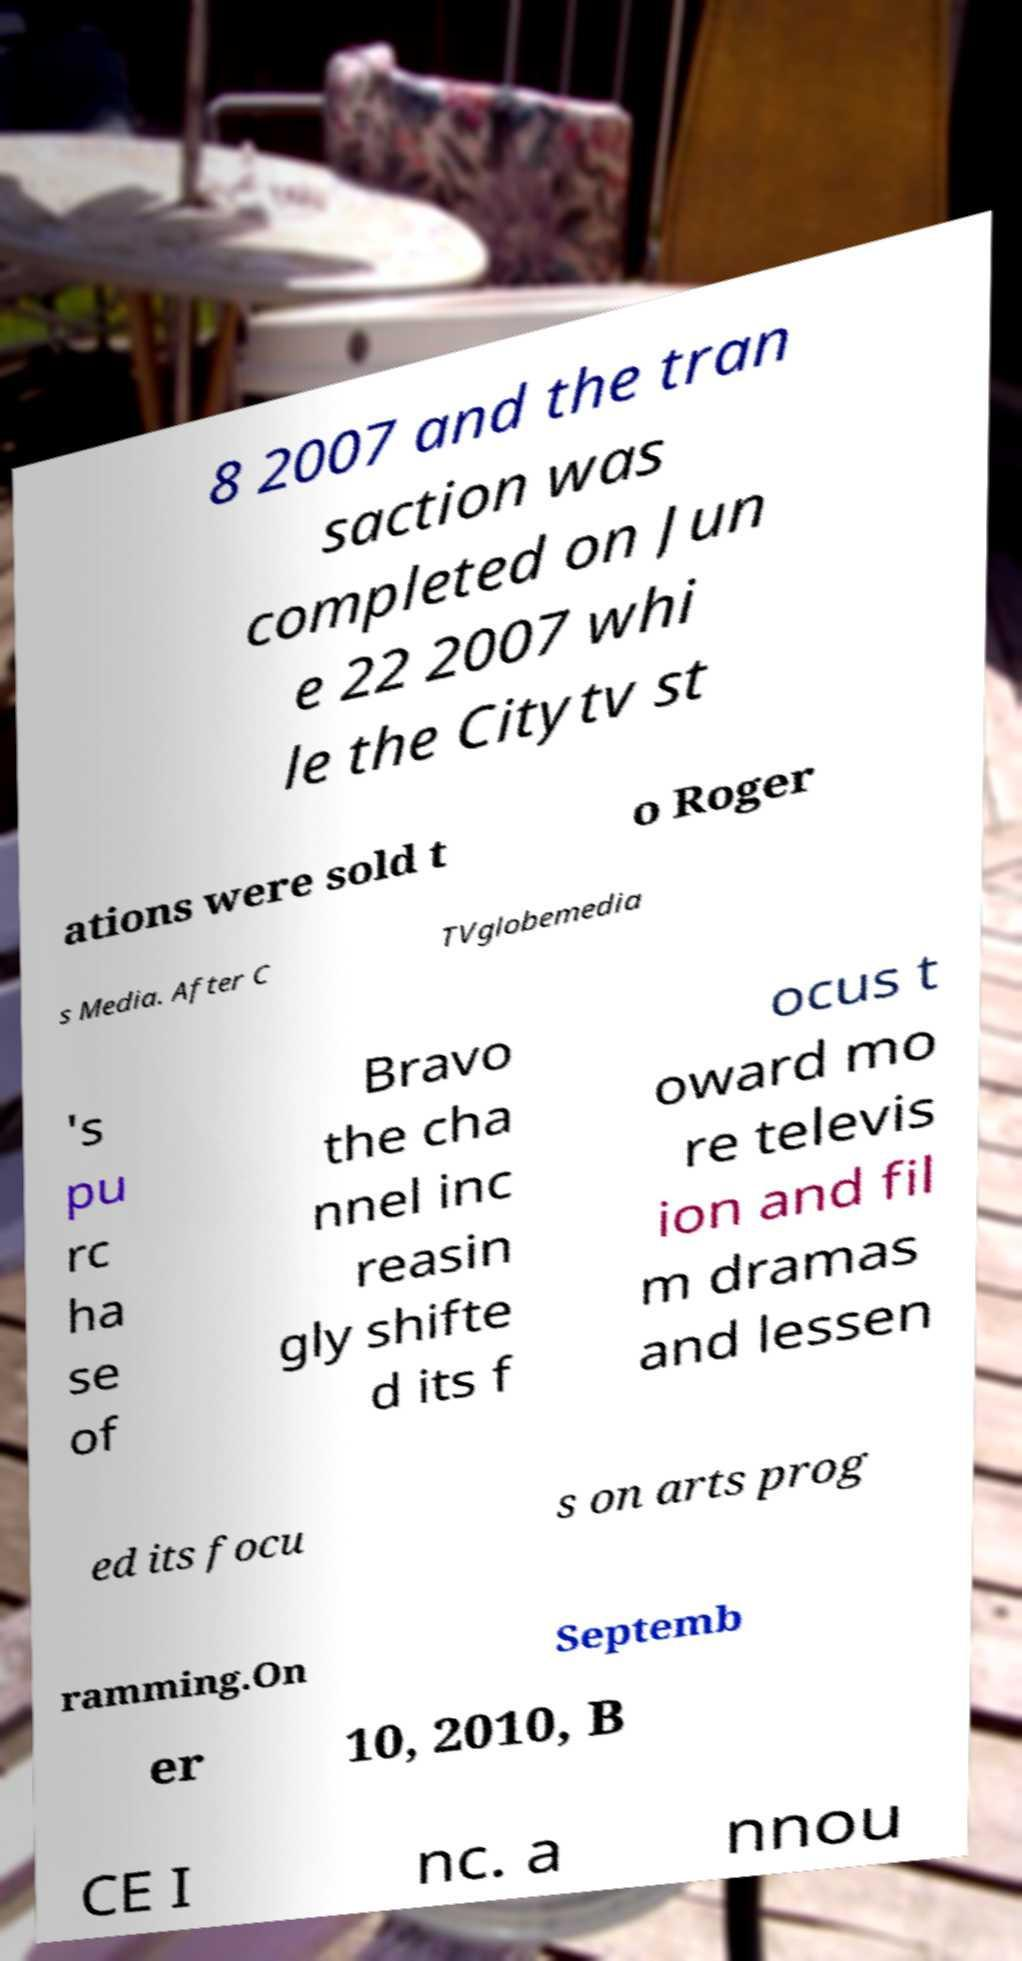Could you assist in decoding the text presented in this image and type it out clearly? 8 2007 and the tran saction was completed on Jun e 22 2007 whi le the Citytv st ations were sold t o Roger s Media. After C TVglobemedia 's pu rc ha se of Bravo the cha nnel inc reasin gly shifte d its f ocus t oward mo re televis ion and fil m dramas and lessen ed its focu s on arts prog ramming.On Septemb er 10, 2010, B CE I nc. a nnou 